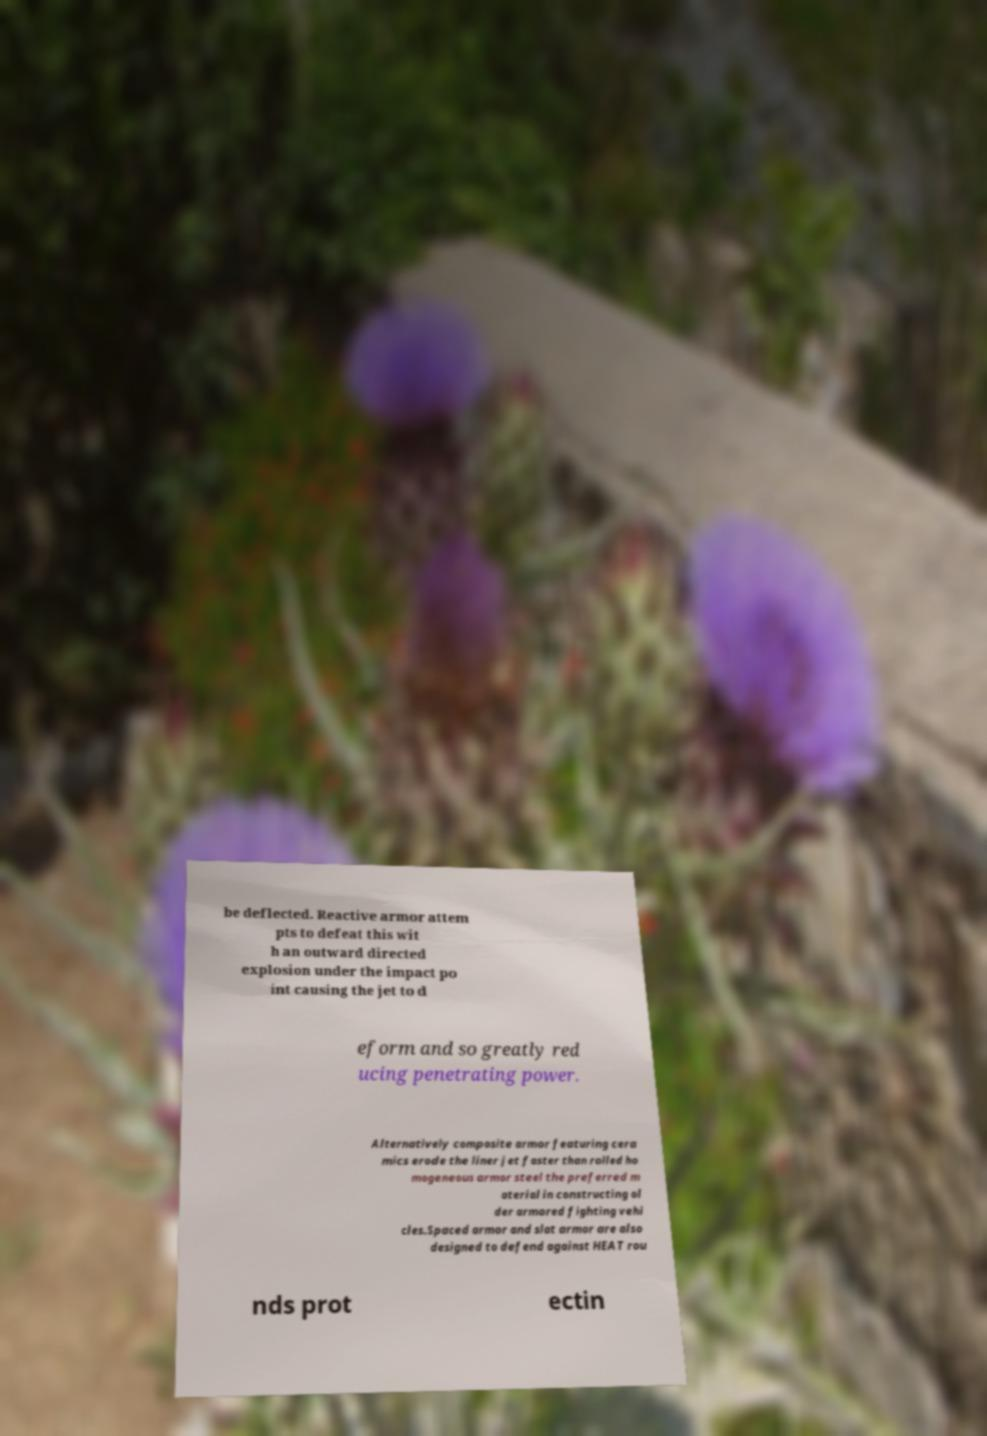What messages or text are displayed in this image? I need them in a readable, typed format. be deflected. Reactive armor attem pts to defeat this wit h an outward directed explosion under the impact po int causing the jet to d eform and so greatly red ucing penetrating power. Alternatively composite armor featuring cera mics erode the liner jet faster than rolled ho mogeneous armor steel the preferred m aterial in constructing ol der armored fighting vehi cles.Spaced armor and slat armor are also designed to defend against HEAT rou nds prot ectin 